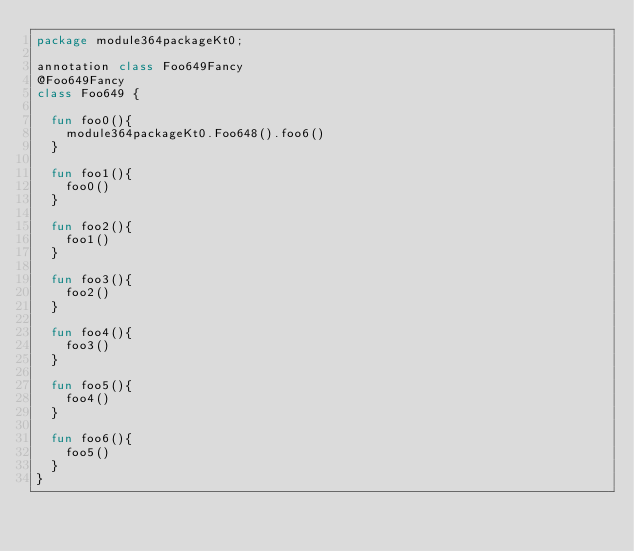Convert code to text. <code><loc_0><loc_0><loc_500><loc_500><_Kotlin_>package module364packageKt0;

annotation class Foo649Fancy
@Foo649Fancy
class Foo649 {

  fun foo0(){
    module364packageKt0.Foo648().foo6()
  }

  fun foo1(){
    foo0()
  }

  fun foo2(){
    foo1()
  }

  fun foo3(){
    foo2()
  }

  fun foo4(){
    foo3()
  }

  fun foo5(){
    foo4()
  }

  fun foo6(){
    foo5()
  }
}</code> 